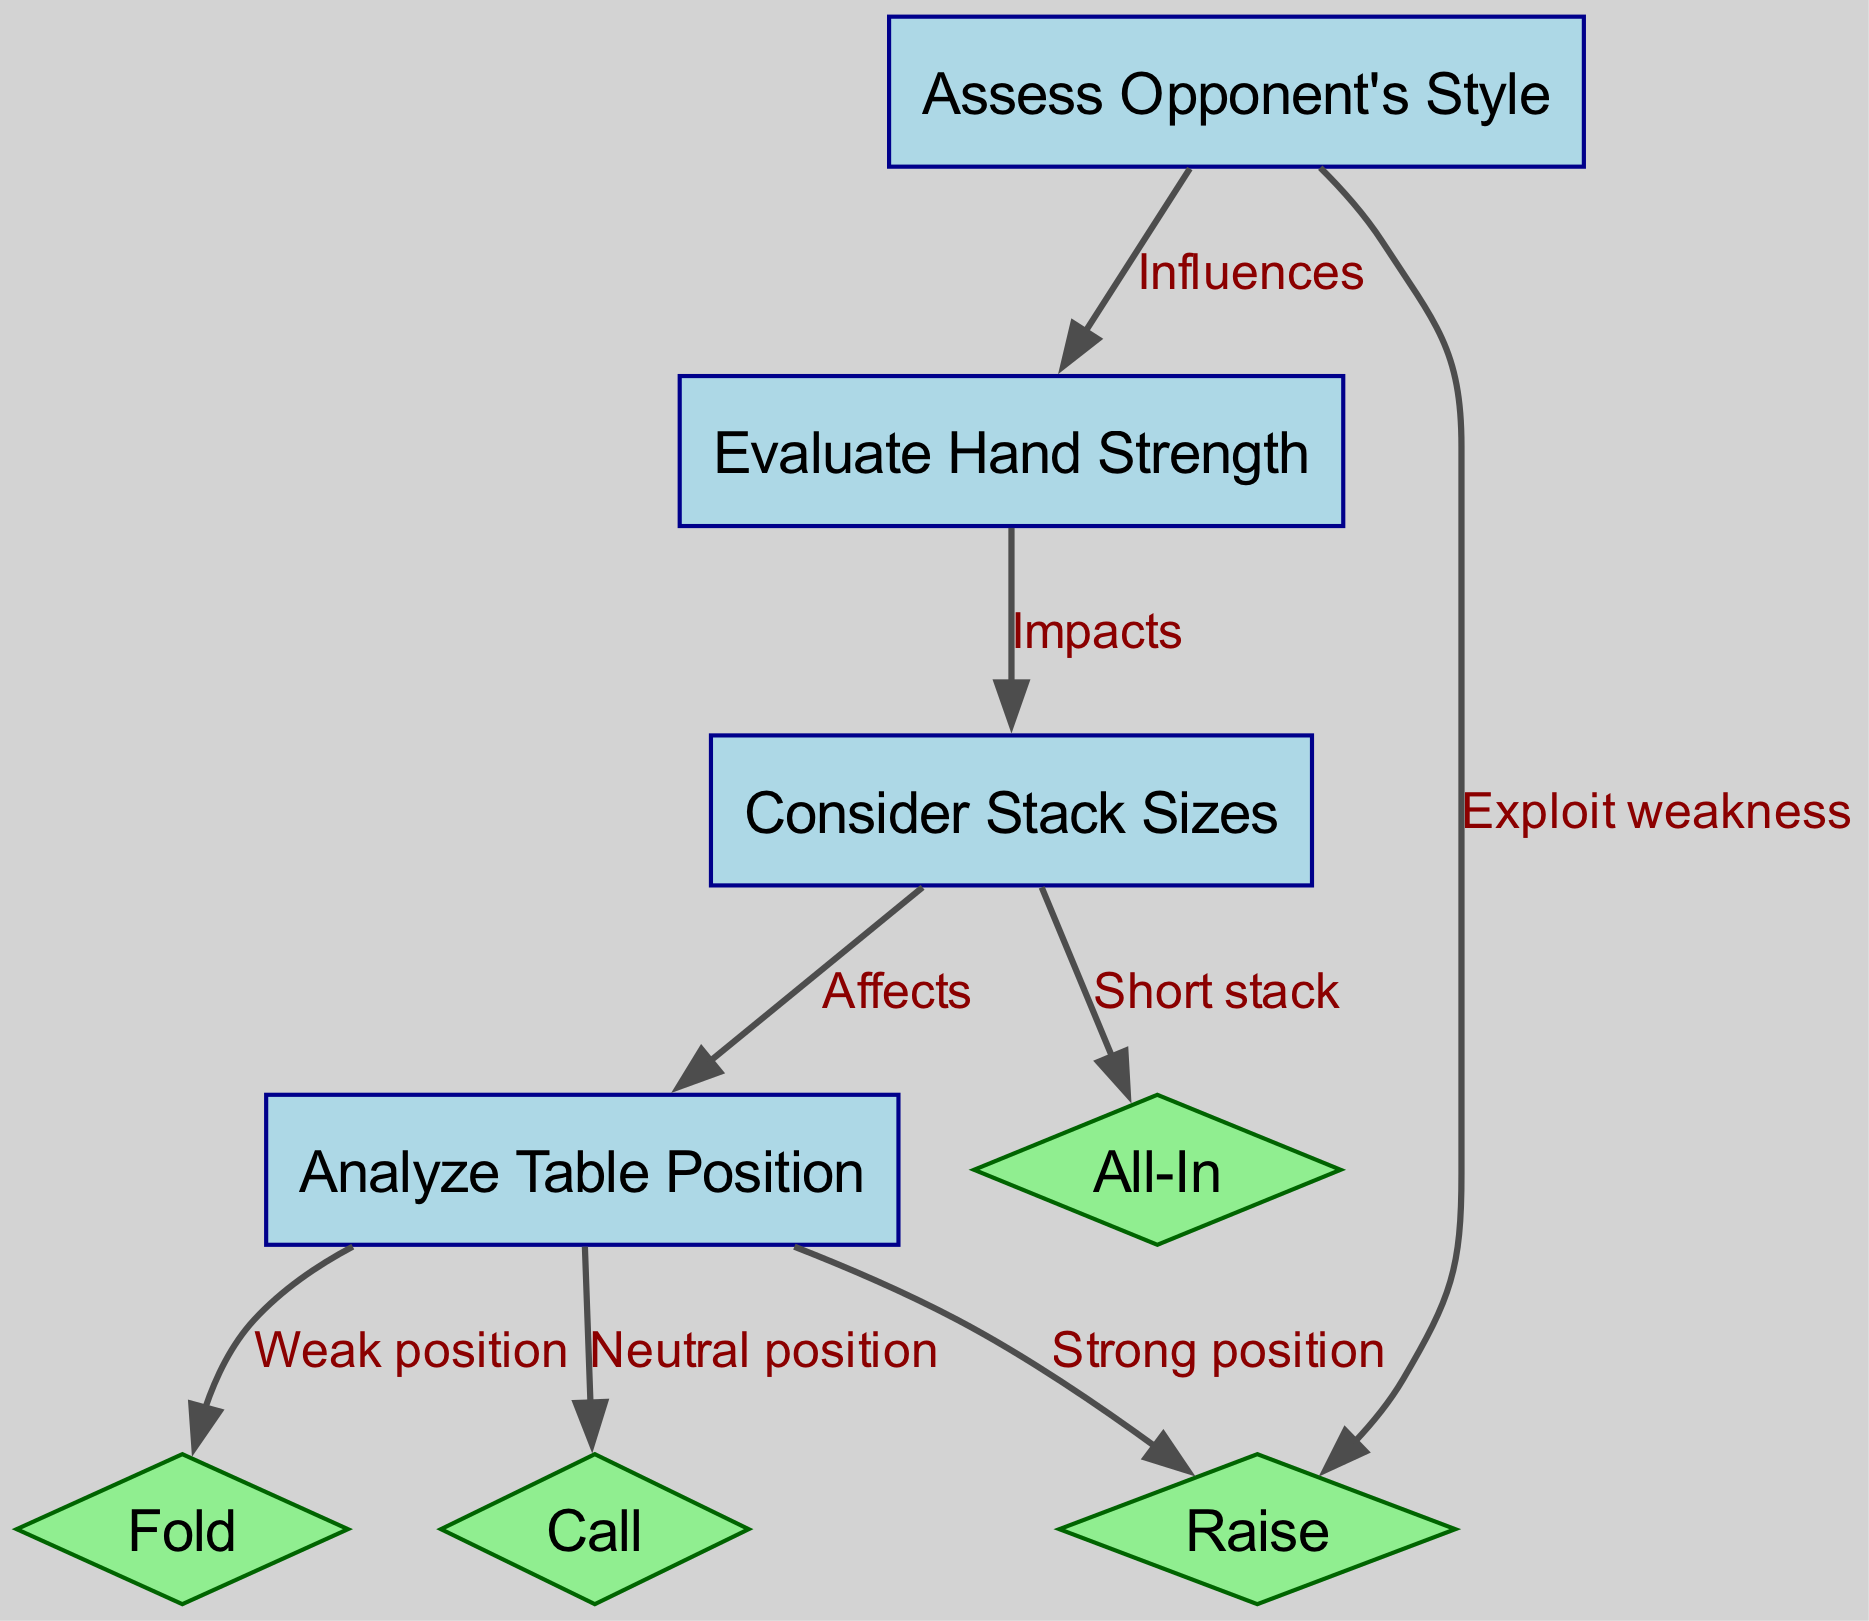What is the total number of nodes in the diagram? The diagram lists a total of 8 nodes, which are the different steps in the poker player decision-making process.
Answer: 8 What label is associated with node 3? Node 3 is labeled "Consider Stack Sizes," indicating this step in the decision-making process related to analyzing stack sizes during the game.
Answer: Consider Stack Sizes Which action is taken when in a weak position? Following the flow from node 4 ("Analyze Table Position"), it leads directly to node 5 ("Fold"), indicating that when in a weak position, the recommended action is to fold.
Answer: Fold What does node 1 influence? Node 1, labeled "Assess Opponent's Style," influences node 2, which is "Evaluate Hand Strength," indicating that the assessment of opponents affects how a player evaluates their own hand.
Answer: Evaluate Hand Strength How many decisions can a player make from a strong position? From node 4 ("Analyze Table Position") in a strong position, a player can make one decision, which is to raise, represented by node 7. Thus, there is one decision pathway stemming from this position.
Answer: 1 What is the relationship between "Consider Stack Sizes" and "All-In"? The relationship is one of impact; "Consider Stack Sizes" (node 3) leads to "All-In" (node 8) specifically when the player has a short stack, suggesting that the player's stack size influences whether they will go all-in.
Answer: Affects Which decision node is influenced by the assessment of opponents? Based on the flow of the diagram, "Raise" (node 7) is one of the decisions influenced directly by assessing the opponent's style, suggesting that the player's decision to raise can exploit perceived weaknesses in their opponents.
Answer: Raise What needs to be evaluated before considering the table position? Before evaluating the table position (node 4), one must evaluate hand strength (node 2), as indicated by the directed edge from node 2 to node 3 in the diagram.
Answer: Evaluate Hand Strength 